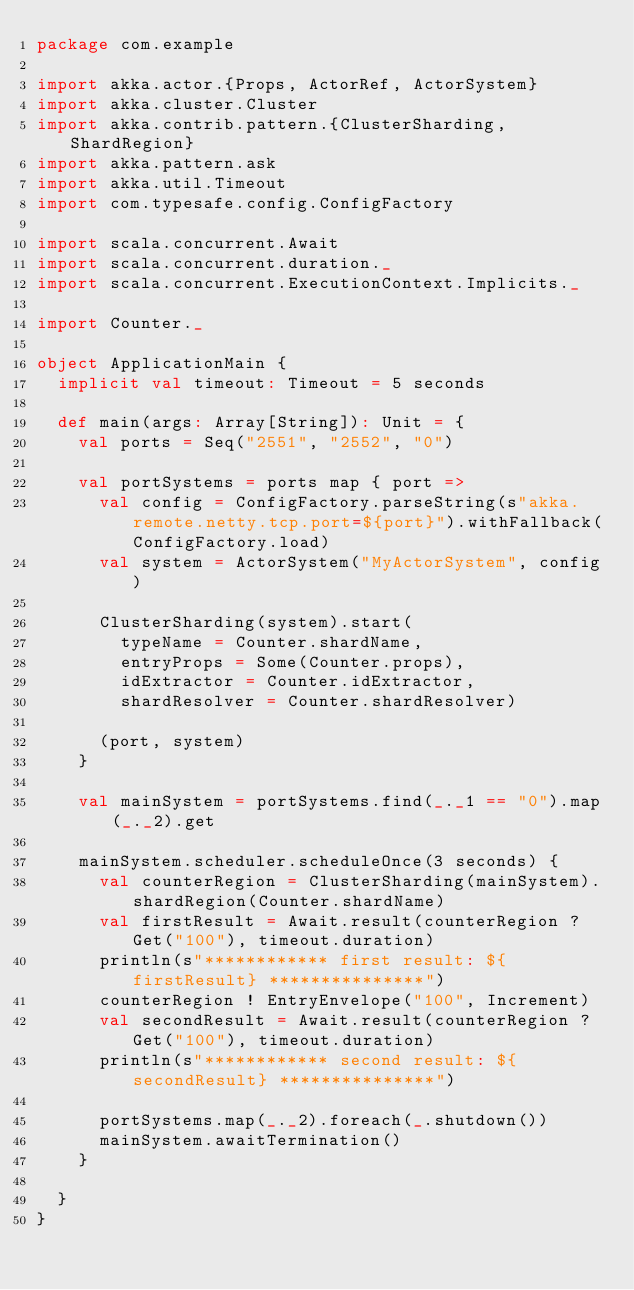Convert code to text. <code><loc_0><loc_0><loc_500><loc_500><_Scala_>package com.example

import akka.actor.{Props, ActorRef, ActorSystem}
import akka.cluster.Cluster
import akka.contrib.pattern.{ClusterSharding, ShardRegion}
import akka.pattern.ask
import akka.util.Timeout
import com.typesafe.config.ConfigFactory

import scala.concurrent.Await
import scala.concurrent.duration._
import scala.concurrent.ExecutionContext.Implicits._

import Counter._

object ApplicationMain {
  implicit val timeout: Timeout = 5 seconds

  def main(args: Array[String]): Unit = {
    val ports = Seq("2551", "2552", "0")

    val portSystems = ports map { port =>
      val config = ConfigFactory.parseString(s"akka.remote.netty.tcp.port=${port}").withFallback(ConfigFactory.load)
      val system = ActorSystem("MyActorSystem", config)

      ClusterSharding(system).start(
        typeName = Counter.shardName,
        entryProps = Some(Counter.props),
        idExtractor = Counter.idExtractor,
        shardResolver = Counter.shardResolver)

      (port, system)
    }

    val mainSystem = portSystems.find(_._1 == "0").map(_._2).get
    
    mainSystem.scheduler.scheduleOnce(3 seconds) {
      val counterRegion = ClusterSharding(mainSystem).shardRegion(Counter.shardName)
      val firstResult = Await.result(counterRegion ? Get("100"), timeout.duration)
      println(s"************ first result: ${firstResult} ***************")
      counterRegion ! EntryEnvelope("100", Increment)
      val secondResult = Await.result(counterRegion ? Get("100"), timeout.duration)
      println(s"************ second result: ${secondResult} ***************")

      portSystems.map(_._2).foreach(_.shutdown())
      mainSystem.awaitTermination()
    }

  }
}</code> 